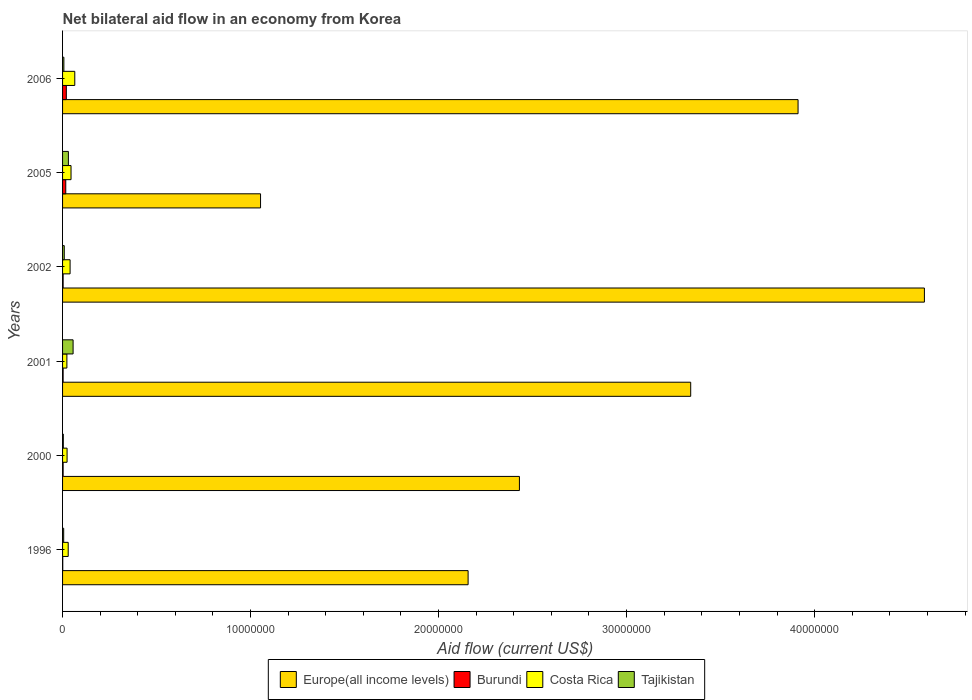How many different coloured bars are there?
Your answer should be very brief. 4. How many groups of bars are there?
Ensure brevity in your answer.  6. Are the number of bars per tick equal to the number of legend labels?
Give a very brief answer. Yes. Are the number of bars on each tick of the Y-axis equal?
Ensure brevity in your answer.  Yes. How many bars are there on the 1st tick from the top?
Make the answer very short. 4. How many bars are there on the 5th tick from the bottom?
Keep it short and to the point. 4. Across all years, what is the minimum net bilateral aid flow in Europe(all income levels)?
Ensure brevity in your answer.  1.05e+07. In which year was the net bilateral aid flow in Europe(all income levels) maximum?
Provide a succinct answer. 2002. In which year was the net bilateral aid flow in Europe(all income levels) minimum?
Your answer should be very brief. 2005. What is the total net bilateral aid flow in Burundi in the graph?
Offer a very short reply. 4.70e+05. What is the difference between the net bilateral aid flow in Europe(all income levels) in 2006 and the net bilateral aid flow in Costa Rica in 2002?
Your answer should be compact. 3.87e+07. What is the average net bilateral aid flow in Costa Rica per year?
Offer a terse response. 3.78e+05. In the year 2006, what is the difference between the net bilateral aid flow in Burundi and net bilateral aid flow in Costa Rica?
Ensure brevity in your answer.  -4.50e+05. In how many years, is the net bilateral aid flow in Burundi greater than 2000000 US$?
Offer a terse response. 0. What is the ratio of the net bilateral aid flow in Tajikistan in 2002 to that in 2006?
Keep it short and to the point. 1.29. Is the net bilateral aid flow in Burundi in 1996 less than that in 2005?
Provide a short and direct response. Yes. Is it the case that in every year, the sum of the net bilateral aid flow in Tajikistan and net bilateral aid flow in Costa Rica is greater than the sum of net bilateral aid flow in Burundi and net bilateral aid flow in Europe(all income levels)?
Offer a very short reply. No. What does the 1st bar from the top in 2006 represents?
Keep it short and to the point. Tajikistan. What does the 1st bar from the bottom in 2001 represents?
Your answer should be compact. Europe(all income levels). Is it the case that in every year, the sum of the net bilateral aid flow in Europe(all income levels) and net bilateral aid flow in Burundi is greater than the net bilateral aid flow in Tajikistan?
Keep it short and to the point. Yes. Are the values on the major ticks of X-axis written in scientific E-notation?
Keep it short and to the point. No. Does the graph contain grids?
Make the answer very short. No. How many legend labels are there?
Give a very brief answer. 4. How are the legend labels stacked?
Ensure brevity in your answer.  Horizontal. What is the title of the graph?
Your response must be concise. Net bilateral aid flow in an economy from Korea. What is the label or title of the X-axis?
Offer a terse response. Aid flow (current US$). What is the Aid flow (current US$) of Europe(all income levels) in 1996?
Offer a terse response. 2.16e+07. What is the Aid flow (current US$) of Europe(all income levels) in 2000?
Your answer should be very brief. 2.43e+07. What is the Aid flow (current US$) in Burundi in 2000?
Provide a succinct answer. 3.00e+04. What is the Aid flow (current US$) of Europe(all income levels) in 2001?
Ensure brevity in your answer.  3.34e+07. What is the Aid flow (current US$) of Costa Rica in 2001?
Give a very brief answer. 2.30e+05. What is the Aid flow (current US$) of Tajikistan in 2001?
Your answer should be very brief. 5.60e+05. What is the Aid flow (current US$) of Europe(all income levels) in 2002?
Make the answer very short. 4.58e+07. What is the Aid flow (current US$) of Burundi in 2002?
Provide a short and direct response. 3.00e+04. What is the Aid flow (current US$) of Costa Rica in 2002?
Give a very brief answer. 4.00e+05. What is the Aid flow (current US$) of Europe(all income levels) in 2005?
Provide a short and direct response. 1.05e+07. What is the Aid flow (current US$) of Europe(all income levels) in 2006?
Ensure brevity in your answer.  3.91e+07. What is the Aid flow (current US$) of Costa Rica in 2006?
Offer a very short reply. 6.50e+05. Across all years, what is the maximum Aid flow (current US$) in Europe(all income levels)?
Your response must be concise. 4.58e+07. Across all years, what is the maximum Aid flow (current US$) in Costa Rica?
Give a very brief answer. 6.50e+05. Across all years, what is the maximum Aid flow (current US$) in Tajikistan?
Provide a short and direct response. 5.60e+05. Across all years, what is the minimum Aid flow (current US$) in Europe(all income levels)?
Provide a short and direct response. 1.05e+07. Across all years, what is the minimum Aid flow (current US$) in Costa Rica?
Make the answer very short. 2.30e+05. What is the total Aid flow (current US$) in Europe(all income levels) in the graph?
Give a very brief answer. 1.75e+08. What is the total Aid flow (current US$) of Burundi in the graph?
Keep it short and to the point. 4.70e+05. What is the total Aid flow (current US$) of Costa Rica in the graph?
Keep it short and to the point. 2.27e+06. What is the total Aid flow (current US$) of Tajikistan in the graph?
Ensure brevity in your answer.  1.13e+06. What is the difference between the Aid flow (current US$) of Europe(all income levels) in 1996 and that in 2000?
Ensure brevity in your answer.  -2.73e+06. What is the difference between the Aid flow (current US$) in Tajikistan in 1996 and that in 2000?
Give a very brief answer. 2.00e+04. What is the difference between the Aid flow (current US$) in Europe(all income levels) in 1996 and that in 2001?
Your response must be concise. -1.18e+07. What is the difference between the Aid flow (current US$) in Costa Rica in 1996 and that in 2001?
Your response must be concise. 7.00e+04. What is the difference between the Aid flow (current US$) of Tajikistan in 1996 and that in 2001?
Make the answer very short. -5.00e+05. What is the difference between the Aid flow (current US$) in Europe(all income levels) in 1996 and that in 2002?
Your answer should be compact. -2.43e+07. What is the difference between the Aid flow (current US$) of Burundi in 1996 and that in 2002?
Your answer should be compact. -2.00e+04. What is the difference between the Aid flow (current US$) in Costa Rica in 1996 and that in 2002?
Make the answer very short. -1.00e+05. What is the difference between the Aid flow (current US$) of Tajikistan in 1996 and that in 2002?
Offer a terse response. -3.00e+04. What is the difference between the Aid flow (current US$) of Europe(all income levels) in 1996 and that in 2005?
Provide a succinct answer. 1.10e+07. What is the difference between the Aid flow (current US$) in Tajikistan in 1996 and that in 2005?
Provide a short and direct response. -2.50e+05. What is the difference between the Aid flow (current US$) of Europe(all income levels) in 1996 and that in 2006?
Provide a succinct answer. -1.76e+07. What is the difference between the Aid flow (current US$) in Costa Rica in 1996 and that in 2006?
Ensure brevity in your answer.  -3.50e+05. What is the difference between the Aid flow (current US$) in Tajikistan in 1996 and that in 2006?
Offer a terse response. -10000. What is the difference between the Aid flow (current US$) of Europe(all income levels) in 2000 and that in 2001?
Your answer should be very brief. -9.11e+06. What is the difference between the Aid flow (current US$) of Burundi in 2000 and that in 2001?
Your response must be concise. 0. What is the difference between the Aid flow (current US$) of Costa Rica in 2000 and that in 2001?
Your answer should be compact. 10000. What is the difference between the Aid flow (current US$) of Tajikistan in 2000 and that in 2001?
Ensure brevity in your answer.  -5.20e+05. What is the difference between the Aid flow (current US$) of Europe(all income levels) in 2000 and that in 2002?
Provide a short and direct response. -2.15e+07. What is the difference between the Aid flow (current US$) of Burundi in 2000 and that in 2002?
Keep it short and to the point. 0. What is the difference between the Aid flow (current US$) of Europe(all income levels) in 2000 and that in 2005?
Ensure brevity in your answer.  1.38e+07. What is the difference between the Aid flow (current US$) in Burundi in 2000 and that in 2005?
Give a very brief answer. -1.40e+05. What is the difference between the Aid flow (current US$) of Costa Rica in 2000 and that in 2005?
Your answer should be compact. -2.10e+05. What is the difference between the Aid flow (current US$) of Tajikistan in 2000 and that in 2005?
Make the answer very short. -2.70e+05. What is the difference between the Aid flow (current US$) of Europe(all income levels) in 2000 and that in 2006?
Provide a succinct answer. -1.48e+07. What is the difference between the Aid flow (current US$) of Burundi in 2000 and that in 2006?
Provide a short and direct response. -1.70e+05. What is the difference between the Aid flow (current US$) in Costa Rica in 2000 and that in 2006?
Your answer should be very brief. -4.10e+05. What is the difference between the Aid flow (current US$) of Tajikistan in 2000 and that in 2006?
Give a very brief answer. -3.00e+04. What is the difference between the Aid flow (current US$) in Europe(all income levels) in 2001 and that in 2002?
Make the answer very short. -1.24e+07. What is the difference between the Aid flow (current US$) of Europe(all income levels) in 2001 and that in 2005?
Your response must be concise. 2.29e+07. What is the difference between the Aid flow (current US$) in Burundi in 2001 and that in 2005?
Keep it short and to the point. -1.40e+05. What is the difference between the Aid flow (current US$) in Costa Rica in 2001 and that in 2005?
Your response must be concise. -2.20e+05. What is the difference between the Aid flow (current US$) in Tajikistan in 2001 and that in 2005?
Offer a very short reply. 2.50e+05. What is the difference between the Aid flow (current US$) of Europe(all income levels) in 2001 and that in 2006?
Keep it short and to the point. -5.71e+06. What is the difference between the Aid flow (current US$) in Costa Rica in 2001 and that in 2006?
Keep it short and to the point. -4.20e+05. What is the difference between the Aid flow (current US$) of Tajikistan in 2001 and that in 2006?
Your answer should be very brief. 4.90e+05. What is the difference between the Aid flow (current US$) in Europe(all income levels) in 2002 and that in 2005?
Your response must be concise. 3.53e+07. What is the difference between the Aid flow (current US$) of Burundi in 2002 and that in 2005?
Provide a short and direct response. -1.40e+05. What is the difference between the Aid flow (current US$) of Costa Rica in 2002 and that in 2005?
Give a very brief answer. -5.00e+04. What is the difference between the Aid flow (current US$) of Europe(all income levels) in 2002 and that in 2006?
Offer a very short reply. 6.72e+06. What is the difference between the Aid flow (current US$) in Burundi in 2002 and that in 2006?
Your answer should be compact. -1.70e+05. What is the difference between the Aid flow (current US$) in Costa Rica in 2002 and that in 2006?
Ensure brevity in your answer.  -2.50e+05. What is the difference between the Aid flow (current US$) of Europe(all income levels) in 2005 and that in 2006?
Offer a terse response. -2.86e+07. What is the difference between the Aid flow (current US$) in Tajikistan in 2005 and that in 2006?
Give a very brief answer. 2.40e+05. What is the difference between the Aid flow (current US$) in Europe(all income levels) in 1996 and the Aid flow (current US$) in Burundi in 2000?
Ensure brevity in your answer.  2.15e+07. What is the difference between the Aid flow (current US$) of Europe(all income levels) in 1996 and the Aid flow (current US$) of Costa Rica in 2000?
Give a very brief answer. 2.13e+07. What is the difference between the Aid flow (current US$) in Europe(all income levels) in 1996 and the Aid flow (current US$) in Tajikistan in 2000?
Provide a succinct answer. 2.15e+07. What is the difference between the Aid flow (current US$) in Burundi in 1996 and the Aid flow (current US$) in Costa Rica in 2000?
Your answer should be very brief. -2.30e+05. What is the difference between the Aid flow (current US$) of Burundi in 1996 and the Aid flow (current US$) of Tajikistan in 2000?
Your response must be concise. -3.00e+04. What is the difference between the Aid flow (current US$) of Costa Rica in 1996 and the Aid flow (current US$) of Tajikistan in 2000?
Offer a very short reply. 2.60e+05. What is the difference between the Aid flow (current US$) in Europe(all income levels) in 1996 and the Aid flow (current US$) in Burundi in 2001?
Provide a short and direct response. 2.15e+07. What is the difference between the Aid flow (current US$) in Europe(all income levels) in 1996 and the Aid flow (current US$) in Costa Rica in 2001?
Your answer should be very brief. 2.13e+07. What is the difference between the Aid flow (current US$) of Europe(all income levels) in 1996 and the Aid flow (current US$) of Tajikistan in 2001?
Keep it short and to the point. 2.10e+07. What is the difference between the Aid flow (current US$) of Burundi in 1996 and the Aid flow (current US$) of Tajikistan in 2001?
Your response must be concise. -5.50e+05. What is the difference between the Aid flow (current US$) in Costa Rica in 1996 and the Aid flow (current US$) in Tajikistan in 2001?
Ensure brevity in your answer.  -2.60e+05. What is the difference between the Aid flow (current US$) of Europe(all income levels) in 1996 and the Aid flow (current US$) of Burundi in 2002?
Offer a terse response. 2.15e+07. What is the difference between the Aid flow (current US$) of Europe(all income levels) in 1996 and the Aid flow (current US$) of Costa Rica in 2002?
Your answer should be very brief. 2.12e+07. What is the difference between the Aid flow (current US$) of Europe(all income levels) in 1996 and the Aid flow (current US$) of Tajikistan in 2002?
Make the answer very short. 2.15e+07. What is the difference between the Aid flow (current US$) in Burundi in 1996 and the Aid flow (current US$) in Costa Rica in 2002?
Offer a terse response. -3.90e+05. What is the difference between the Aid flow (current US$) in Burundi in 1996 and the Aid flow (current US$) in Tajikistan in 2002?
Offer a very short reply. -8.00e+04. What is the difference between the Aid flow (current US$) in Costa Rica in 1996 and the Aid flow (current US$) in Tajikistan in 2002?
Make the answer very short. 2.10e+05. What is the difference between the Aid flow (current US$) of Europe(all income levels) in 1996 and the Aid flow (current US$) of Burundi in 2005?
Provide a succinct answer. 2.14e+07. What is the difference between the Aid flow (current US$) in Europe(all income levels) in 1996 and the Aid flow (current US$) in Costa Rica in 2005?
Offer a very short reply. 2.11e+07. What is the difference between the Aid flow (current US$) of Europe(all income levels) in 1996 and the Aid flow (current US$) of Tajikistan in 2005?
Your answer should be very brief. 2.13e+07. What is the difference between the Aid flow (current US$) in Burundi in 1996 and the Aid flow (current US$) in Costa Rica in 2005?
Your answer should be very brief. -4.40e+05. What is the difference between the Aid flow (current US$) in Burundi in 1996 and the Aid flow (current US$) in Tajikistan in 2005?
Your answer should be compact. -3.00e+05. What is the difference between the Aid flow (current US$) in Europe(all income levels) in 1996 and the Aid flow (current US$) in Burundi in 2006?
Keep it short and to the point. 2.14e+07. What is the difference between the Aid flow (current US$) of Europe(all income levels) in 1996 and the Aid flow (current US$) of Costa Rica in 2006?
Make the answer very short. 2.09e+07. What is the difference between the Aid flow (current US$) of Europe(all income levels) in 1996 and the Aid flow (current US$) of Tajikistan in 2006?
Your response must be concise. 2.15e+07. What is the difference between the Aid flow (current US$) in Burundi in 1996 and the Aid flow (current US$) in Costa Rica in 2006?
Offer a very short reply. -6.40e+05. What is the difference between the Aid flow (current US$) of Burundi in 1996 and the Aid flow (current US$) of Tajikistan in 2006?
Your response must be concise. -6.00e+04. What is the difference between the Aid flow (current US$) of Europe(all income levels) in 2000 and the Aid flow (current US$) of Burundi in 2001?
Offer a terse response. 2.43e+07. What is the difference between the Aid flow (current US$) of Europe(all income levels) in 2000 and the Aid flow (current US$) of Costa Rica in 2001?
Offer a very short reply. 2.41e+07. What is the difference between the Aid flow (current US$) in Europe(all income levels) in 2000 and the Aid flow (current US$) in Tajikistan in 2001?
Your response must be concise. 2.37e+07. What is the difference between the Aid flow (current US$) of Burundi in 2000 and the Aid flow (current US$) of Tajikistan in 2001?
Ensure brevity in your answer.  -5.30e+05. What is the difference between the Aid flow (current US$) of Costa Rica in 2000 and the Aid flow (current US$) of Tajikistan in 2001?
Offer a terse response. -3.20e+05. What is the difference between the Aid flow (current US$) of Europe(all income levels) in 2000 and the Aid flow (current US$) of Burundi in 2002?
Your answer should be compact. 2.43e+07. What is the difference between the Aid flow (current US$) of Europe(all income levels) in 2000 and the Aid flow (current US$) of Costa Rica in 2002?
Offer a terse response. 2.39e+07. What is the difference between the Aid flow (current US$) in Europe(all income levels) in 2000 and the Aid flow (current US$) in Tajikistan in 2002?
Provide a succinct answer. 2.42e+07. What is the difference between the Aid flow (current US$) of Burundi in 2000 and the Aid flow (current US$) of Costa Rica in 2002?
Provide a short and direct response. -3.70e+05. What is the difference between the Aid flow (current US$) of Burundi in 2000 and the Aid flow (current US$) of Tajikistan in 2002?
Offer a very short reply. -6.00e+04. What is the difference between the Aid flow (current US$) of Costa Rica in 2000 and the Aid flow (current US$) of Tajikistan in 2002?
Give a very brief answer. 1.50e+05. What is the difference between the Aid flow (current US$) in Europe(all income levels) in 2000 and the Aid flow (current US$) in Burundi in 2005?
Offer a very short reply. 2.41e+07. What is the difference between the Aid flow (current US$) in Europe(all income levels) in 2000 and the Aid flow (current US$) in Costa Rica in 2005?
Offer a terse response. 2.38e+07. What is the difference between the Aid flow (current US$) of Europe(all income levels) in 2000 and the Aid flow (current US$) of Tajikistan in 2005?
Offer a very short reply. 2.40e+07. What is the difference between the Aid flow (current US$) of Burundi in 2000 and the Aid flow (current US$) of Costa Rica in 2005?
Ensure brevity in your answer.  -4.20e+05. What is the difference between the Aid flow (current US$) in Burundi in 2000 and the Aid flow (current US$) in Tajikistan in 2005?
Keep it short and to the point. -2.80e+05. What is the difference between the Aid flow (current US$) in Costa Rica in 2000 and the Aid flow (current US$) in Tajikistan in 2005?
Your response must be concise. -7.00e+04. What is the difference between the Aid flow (current US$) of Europe(all income levels) in 2000 and the Aid flow (current US$) of Burundi in 2006?
Give a very brief answer. 2.41e+07. What is the difference between the Aid flow (current US$) in Europe(all income levels) in 2000 and the Aid flow (current US$) in Costa Rica in 2006?
Give a very brief answer. 2.36e+07. What is the difference between the Aid flow (current US$) of Europe(all income levels) in 2000 and the Aid flow (current US$) of Tajikistan in 2006?
Ensure brevity in your answer.  2.42e+07. What is the difference between the Aid flow (current US$) of Burundi in 2000 and the Aid flow (current US$) of Costa Rica in 2006?
Your response must be concise. -6.20e+05. What is the difference between the Aid flow (current US$) in Costa Rica in 2000 and the Aid flow (current US$) in Tajikistan in 2006?
Give a very brief answer. 1.70e+05. What is the difference between the Aid flow (current US$) of Europe(all income levels) in 2001 and the Aid flow (current US$) of Burundi in 2002?
Your answer should be very brief. 3.34e+07. What is the difference between the Aid flow (current US$) in Europe(all income levels) in 2001 and the Aid flow (current US$) in Costa Rica in 2002?
Your answer should be compact. 3.30e+07. What is the difference between the Aid flow (current US$) of Europe(all income levels) in 2001 and the Aid flow (current US$) of Tajikistan in 2002?
Your response must be concise. 3.33e+07. What is the difference between the Aid flow (current US$) in Burundi in 2001 and the Aid flow (current US$) in Costa Rica in 2002?
Give a very brief answer. -3.70e+05. What is the difference between the Aid flow (current US$) of Europe(all income levels) in 2001 and the Aid flow (current US$) of Burundi in 2005?
Offer a very short reply. 3.32e+07. What is the difference between the Aid flow (current US$) of Europe(all income levels) in 2001 and the Aid flow (current US$) of Costa Rica in 2005?
Offer a very short reply. 3.30e+07. What is the difference between the Aid flow (current US$) in Europe(all income levels) in 2001 and the Aid flow (current US$) in Tajikistan in 2005?
Provide a short and direct response. 3.31e+07. What is the difference between the Aid flow (current US$) of Burundi in 2001 and the Aid flow (current US$) of Costa Rica in 2005?
Ensure brevity in your answer.  -4.20e+05. What is the difference between the Aid flow (current US$) in Burundi in 2001 and the Aid flow (current US$) in Tajikistan in 2005?
Give a very brief answer. -2.80e+05. What is the difference between the Aid flow (current US$) in Europe(all income levels) in 2001 and the Aid flow (current US$) in Burundi in 2006?
Ensure brevity in your answer.  3.32e+07. What is the difference between the Aid flow (current US$) of Europe(all income levels) in 2001 and the Aid flow (current US$) of Costa Rica in 2006?
Your answer should be very brief. 3.28e+07. What is the difference between the Aid flow (current US$) of Europe(all income levels) in 2001 and the Aid flow (current US$) of Tajikistan in 2006?
Provide a succinct answer. 3.33e+07. What is the difference between the Aid flow (current US$) of Burundi in 2001 and the Aid flow (current US$) of Costa Rica in 2006?
Keep it short and to the point. -6.20e+05. What is the difference between the Aid flow (current US$) in Burundi in 2001 and the Aid flow (current US$) in Tajikistan in 2006?
Provide a short and direct response. -4.00e+04. What is the difference between the Aid flow (current US$) of Europe(all income levels) in 2002 and the Aid flow (current US$) of Burundi in 2005?
Keep it short and to the point. 4.57e+07. What is the difference between the Aid flow (current US$) of Europe(all income levels) in 2002 and the Aid flow (current US$) of Costa Rica in 2005?
Give a very brief answer. 4.54e+07. What is the difference between the Aid flow (current US$) in Europe(all income levels) in 2002 and the Aid flow (current US$) in Tajikistan in 2005?
Offer a very short reply. 4.55e+07. What is the difference between the Aid flow (current US$) of Burundi in 2002 and the Aid flow (current US$) of Costa Rica in 2005?
Your answer should be compact. -4.20e+05. What is the difference between the Aid flow (current US$) of Burundi in 2002 and the Aid flow (current US$) of Tajikistan in 2005?
Keep it short and to the point. -2.80e+05. What is the difference between the Aid flow (current US$) of Costa Rica in 2002 and the Aid flow (current US$) of Tajikistan in 2005?
Your answer should be compact. 9.00e+04. What is the difference between the Aid flow (current US$) in Europe(all income levels) in 2002 and the Aid flow (current US$) in Burundi in 2006?
Provide a succinct answer. 4.56e+07. What is the difference between the Aid flow (current US$) of Europe(all income levels) in 2002 and the Aid flow (current US$) of Costa Rica in 2006?
Offer a terse response. 4.52e+07. What is the difference between the Aid flow (current US$) of Europe(all income levels) in 2002 and the Aid flow (current US$) of Tajikistan in 2006?
Keep it short and to the point. 4.58e+07. What is the difference between the Aid flow (current US$) of Burundi in 2002 and the Aid flow (current US$) of Costa Rica in 2006?
Give a very brief answer. -6.20e+05. What is the difference between the Aid flow (current US$) of Costa Rica in 2002 and the Aid flow (current US$) of Tajikistan in 2006?
Your answer should be compact. 3.30e+05. What is the difference between the Aid flow (current US$) of Europe(all income levels) in 2005 and the Aid flow (current US$) of Burundi in 2006?
Your response must be concise. 1.03e+07. What is the difference between the Aid flow (current US$) of Europe(all income levels) in 2005 and the Aid flow (current US$) of Costa Rica in 2006?
Ensure brevity in your answer.  9.88e+06. What is the difference between the Aid flow (current US$) in Europe(all income levels) in 2005 and the Aid flow (current US$) in Tajikistan in 2006?
Ensure brevity in your answer.  1.05e+07. What is the difference between the Aid flow (current US$) of Burundi in 2005 and the Aid flow (current US$) of Costa Rica in 2006?
Provide a short and direct response. -4.80e+05. What is the difference between the Aid flow (current US$) in Burundi in 2005 and the Aid flow (current US$) in Tajikistan in 2006?
Make the answer very short. 1.00e+05. What is the difference between the Aid flow (current US$) in Costa Rica in 2005 and the Aid flow (current US$) in Tajikistan in 2006?
Provide a short and direct response. 3.80e+05. What is the average Aid flow (current US$) of Europe(all income levels) per year?
Offer a terse response. 2.91e+07. What is the average Aid flow (current US$) of Burundi per year?
Offer a terse response. 7.83e+04. What is the average Aid flow (current US$) in Costa Rica per year?
Your answer should be very brief. 3.78e+05. What is the average Aid flow (current US$) in Tajikistan per year?
Offer a terse response. 1.88e+05. In the year 1996, what is the difference between the Aid flow (current US$) of Europe(all income levels) and Aid flow (current US$) of Burundi?
Make the answer very short. 2.16e+07. In the year 1996, what is the difference between the Aid flow (current US$) of Europe(all income levels) and Aid flow (current US$) of Costa Rica?
Provide a succinct answer. 2.13e+07. In the year 1996, what is the difference between the Aid flow (current US$) in Europe(all income levels) and Aid flow (current US$) in Tajikistan?
Make the answer very short. 2.15e+07. In the year 2000, what is the difference between the Aid flow (current US$) in Europe(all income levels) and Aid flow (current US$) in Burundi?
Your answer should be compact. 2.43e+07. In the year 2000, what is the difference between the Aid flow (current US$) in Europe(all income levels) and Aid flow (current US$) in Costa Rica?
Your answer should be very brief. 2.41e+07. In the year 2000, what is the difference between the Aid flow (current US$) in Europe(all income levels) and Aid flow (current US$) in Tajikistan?
Offer a very short reply. 2.43e+07. In the year 2000, what is the difference between the Aid flow (current US$) in Burundi and Aid flow (current US$) in Tajikistan?
Make the answer very short. -10000. In the year 2000, what is the difference between the Aid flow (current US$) in Costa Rica and Aid flow (current US$) in Tajikistan?
Your answer should be compact. 2.00e+05. In the year 2001, what is the difference between the Aid flow (current US$) in Europe(all income levels) and Aid flow (current US$) in Burundi?
Ensure brevity in your answer.  3.34e+07. In the year 2001, what is the difference between the Aid flow (current US$) of Europe(all income levels) and Aid flow (current US$) of Costa Rica?
Ensure brevity in your answer.  3.32e+07. In the year 2001, what is the difference between the Aid flow (current US$) in Europe(all income levels) and Aid flow (current US$) in Tajikistan?
Your answer should be very brief. 3.28e+07. In the year 2001, what is the difference between the Aid flow (current US$) in Burundi and Aid flow (current US$) in Costa Rica?
Provide a short and direct response. -2.00e+05. In the year 2001, what is the difference between the Aid flow (current US$) of Burundi and Aid flow (current US$) of Tajikistan?
Provide a short and direct response. -5.30e+05. In the year 2001, what is the difference between the Aid flow (current US$) of Costa Rica and Aid flow (current US$) of Tajikistan?
Offer a terse response. -3.30e+05. In the year 2002, what is the difference between the Aid flow (current US$) in Europe(all income levels) and Aid flow (current US$) in Burundi?
Offer a very short reply. 4.58e+07. In the year 2002, what is the difference between the Aid flow (current US$) of Europe(all income levels) and Aid flow (current US$) of Costa Rica?
Provide a succinct answer. 4.54e+07. In the year 2002, what is the difference between the Aid flow (current US$) of Europe(all income levels) and Aid flow (current US$) of Tajikistan?
Ensure brevity in your answer.  4.58e+07. In the year 2002, what is the difference between the Aid flow (current US$) in Burundi and Aid flow (current US$) in Costa Rica?
Keep it short and to the point. -3.70e+05. In the year 2002, what is the difference between the Aid flow (current US$) in Burundi and Aid flow (current US$) in Tajikistan?
Provide a succinct answer. -6.00e+04. In the year 2002, what is the difference between the Aid flow (current US$) in Costa Rica and Aid flow (current US$) in Tajikistan?
Provide a short and direct response. 3.10e+05. In the year 2005, what is the difference between the Aid flow (current US$) of Europe(all income levels) and Aid flow (current US$) of Burundi?
Your answer should be very brief. 1.04e+07. In the year 2005, what is the difference between the Aid flow (current US$) in Europe(all income levels) and Aid flow (current US$) in Costa Rica?
Your answer should be compact. 1.01e+07. In the year 2005, what is the difference between the Aid flow (current US$) in Europe(all income levels) and Aid flow (current US$) in Tajikistan?
Your answer should be very brief. 1.02e+07. In the year 2005, what is the difference between the Aid flow (current US$) in Burundi and Aid flow (current US$) in Costa Rica?
Your answer should be very brief. -2.80e+05. In the year 2005, what is the difference between the Aid flow (current US$) of Burundi and Aid flow (current US$) of Tajikistan?
Provide a short and direct response. -1.40e+05. In the year 2006, what is the difference between the Aid flow (current US$) of Europe(all income levels) and Aid flow (current US$) of Burundi?
Give a very brief answer. 3.89e+07. In the year 2006, what is the difference between the Aid flow (current US$) in Europe(all income levels) and Aid flow (current US$) in Costa Rica?
Your answer should be compact. 3.85e+07. In the year 2006, what is the difference between the Aid flow (current US$) in Europe(all income levels) and Aid flow (current US$) in Tajikistan?
Make the answer very short. 3.90e+07. In the year 2006, what is the difference between the Aid flow (current US$) of Burundi and Aid flow (current US$) of Costa Rica?
Give a very brief answer. -4.50e+05. In the year 2006, what is the difference between the Aid flow (current US$) of Burundi and Aid flow (current US$) of Tajikistan?
Your response must be concise. 1.30e+05. In the year 2006, what is the difference between the Aid flow (current US$) of Costa Rica and Aid flow (current US$) of Tajikistan?
Your response must be concise. 5.80e+05. What is the ratio of the Aid flow (current US$) of Europe(all income levels) in 1996 to that in 2000?
Keep it short and to the point. 0.89. What is the ratio of the Aid flow (current US$) of Costa Rica in 1996 to that in 2000?
Provide a succinct answer. 1.25. What is the ratio of the Aid flow (current US$) in Tajikistan in 1996 to that in 2000?
Give a very brief answer. 1.5. What is the ratio of the Aid flow (current US$) of Europe(all income levels) in 1996 to that in 2001?
Your response must be concise. 0.65. What is the ratio of the Aid flow (current US$) in Costa Rica in 1996 to that in 2001?
Provide a short and direct response. 1.3. What is the ratio of the Aid flow (current US$) of Tajikistan in 1996 to that in 2001?
Ensure brevity in your answer.  0.11. What is the ratio of the Aid flow (current US$) in Europe(all income levels) in 1996 to that in 2002?
Your response must be concise. 0.47. What is the ratio of the Aid flow (current US$) of Burundi in 1996 to that in 2002?
Your response must be concise. 0.33. What is the ratio of the Aid flow (current US$) in Europe(all income levels) in 1996 to that in 2005?
Make the answer very short. 2.05. What is the ratio of the Aid flow (current US$) in Burundi in 1996 to that in 2005?
Your answer should be compact. 0.06. What is the ratio of the Aid flow (current US$) in Costa Rica in 1996 to that in 2005?
Your answer should be compact. 0.67. What is the ratio of the Aid flow (current US$) of Tajikistan in 1996 to that in 2005?
Your answer should be very brief. 0.19. What is the ratio of the Aid flow (current US$) in Europe(all income levels) in 1996 to that in 2006?
Make the answer very short. 0.55. What is the ratio of the Aid flow (current US$) of Costa Rica in 1996 to that in 2006?
Offer a very short reply. 0.46. What is the ratio of the Aid flow (current US$) in Europe(all income levels) in 2000 to that in 2001?
Your answer should be very brief. 0.73. What is the ratio of the Aid flow (current US$) of Costa Rica in 2000 to that in 2001?
Your answer should be very brief. 1.04. What is the ratio of the Aid flow (current US$) of Tajikistan in 2000 to that in 2001?
Ensure brevity in your answer.  0.07. What is the ratio of the Aid flow (current US$) of Europe(all income levels) in 2000 to that in 2002?
Keep it short and to the point. 0.53. What is the ratio of the Aid flow (current US$) in Burundi in 2000 to that in 2002?
Offer a very short reply. 1. What is the ratio of the Aid flow (current US$) of Costa Rica in 2000 to that in 2002?
Ensure brevity in your answer.  0.6. What is the ratio of the Aid flow (current US$) in Tajikistan in 2000 to that in 2002?
Keep it short and to the point. 0.44. What is the ratio of the Aid flow (current US$) of Europe(all income levels) in 2000 to that in 2005?
Your answer should be compact. 2.31. What is the ratio of the Aid flow (current US$) in Burundi in 2000 to that in 2005?
Your response must be concise. 0.18. What is the ratio of the Aid flow (current US$) in Costa Rica in 2000 to that in 2005?
Provide a succinct answer. 0.53. What is the ratio of the Aid flow (current US$) of Tajikistan in 2000 to that in 2005?
Your answer should be compact. 0.13. What is the ratio of the Aid flow (current US$) in Europe(all income levels) in 2000 to that in 2006?
Your response must be concise. 0.62. What is the ratio of the Aid flow (current US$) in Burundi in 2000 to that in 2006?
Make the answer very short. 0.15. What is the ratio of the Aid flow (current US$) of Costa Rica in 2000 to that in 2006?
Your answer should be very brief. 0.37. What is the ratio of the Aid flow (current US$) in Europe(all income levels) in 2001 to that in 2002?
Provide a short and direct response. 0.73. What is the ratio of the Aid flow (current US$) of Costa Rica in 2001 to that in 2002?
Give a very brief answer. 0.57. What is the ratio of the Aid flow (current US$) in Tajikistan in 2001 to that in 2002?
Offer a terse response. 6.22. What is the ratio of the Aid flow (current US$) of Europe(all income levels) in 2001 to that in 2005?
Give a very brief answer. 3.17. What is the ratio of the Aid flow (current US$) of Burundi in 2001 to that in 2005?
Give a very brief answer. 0.18. What is the ratio of the Aid flow (current US$) in Costa Rica in 2001 to that in 2005?
Ensure brevity in your answer.  0.51. What is the ratio of the Aid flow (current US$) of Tajikistan in 2001 to that in 2005?
Make the answer very short. 1.81. What is the ratio of the Aid flow (current US$) in Europe(all income levels) in 2001 to that in 2006?
Ensure brevity in your answer.  0.85. What is the ratio of the Aid flow (current US$) in Burundi in 2001 to that in 2006?
Your response must be concise. 0.15. What is the ratio of the Aid flow (current US$) of Costa Rica in 2001 to that in 2006?
Your answer should be compact. 0.35. What is the ratio of the Aid flow (current US$) of Europe(all income levels) in 2002 to that in 2005?
Give a very brief answer. 4.35. What is the ratio of the Aid flow (current US$) in Burundi in 2002 to that in 2005?
Your response must be concise. 0.18. What is the ratio of the Aid flow (current US$) in Tajikistan in 2002 to that in 2005?
Offer a very short reply. 0.29. What is the ratio of the Aid flow (current US$) of Europe(all income levels) in 2002 to that in 2006?
Your answer should be very brief. 1.17. What is the ratio of the Aid flow (current US$) in Costa Rica in 2002 to that in 2006?
Your answer should be compact. 0.62. What is the ratio of the Aid flow (current US$) in Europe(all income levels) in 2005 to that in 2006?
Give a very brief answer. 0.27. What is the ratio of the Aid flow (current US$) in Costa Rica in 2005 to that in 2006?
Your answer should be compact. 0.69. What is the ratio of the Aid flow (current US$) of Tajikistan in 2005 to that in 2006?
Keep it short and to the point. 4.43. What is the difference between the highest and the second highest Aid flow (current US$) in Europe(all income levels)?
Provide a short and direct response. 6.72e+06. What is the difference between the highest and the second highest Aid flow (current US$) of Costa Rica?
Make the answer very short. 2.00e+05. What is the difference between the highest and the second highest Aid flow (current US$) of Tajikistan?
Make the answer very short. 2.50e+05. What is the difference between the highest and the lowest Aid flow (current US$) in Europe(all income levels)?
Provide a short and direct response. 3.53e+07. What is the difference between the highest and the lowest Aid flow (current US$) in Burundi?
Make the answer very short. 1.90e+05. What is the difference between the highest and the lowest Aid flow (current US$) of Tajikistan?
Offer a terse response. 5.20e+05. 